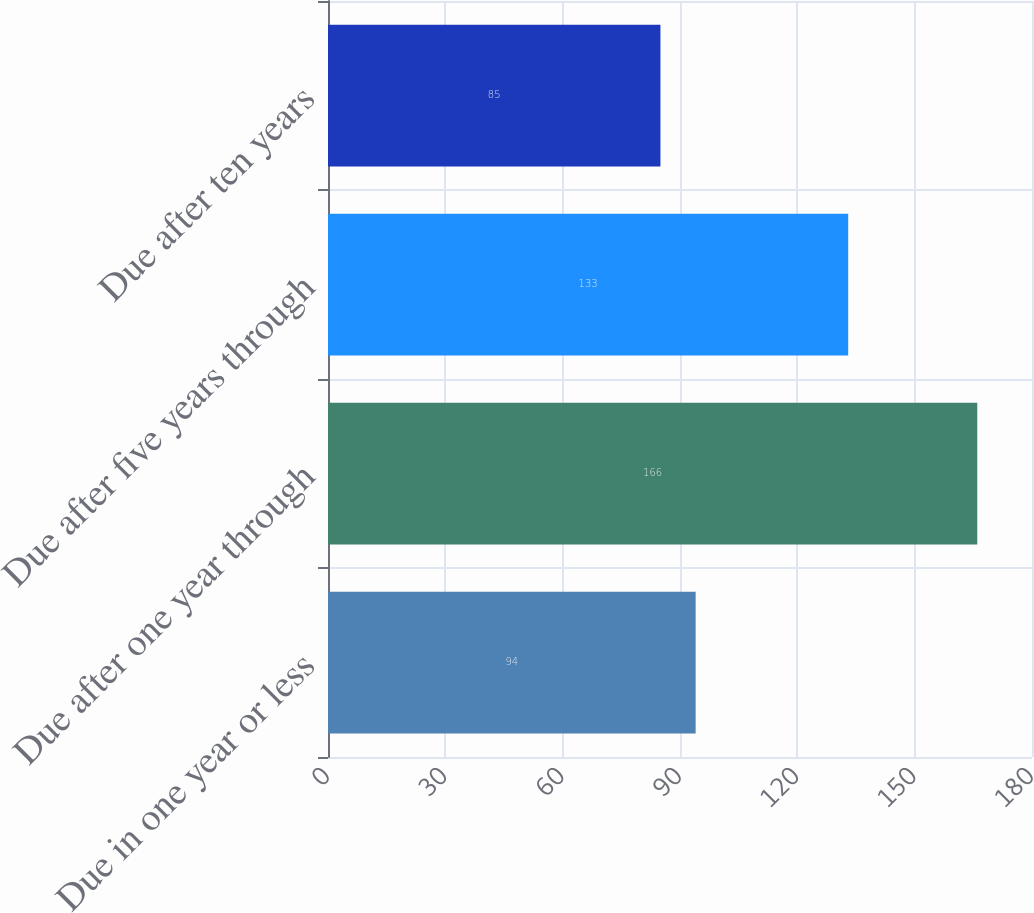<chart> <loc_0><loc_0><loc_500><loc_500><bar_chart><fcel>Due in one year or less<fcel>Due after one year through<fcel>Due after five years through<fcel>Due after ten years<nl><fcel>94<fcel>166<fcel>133<fcel>85<nl></chart> 